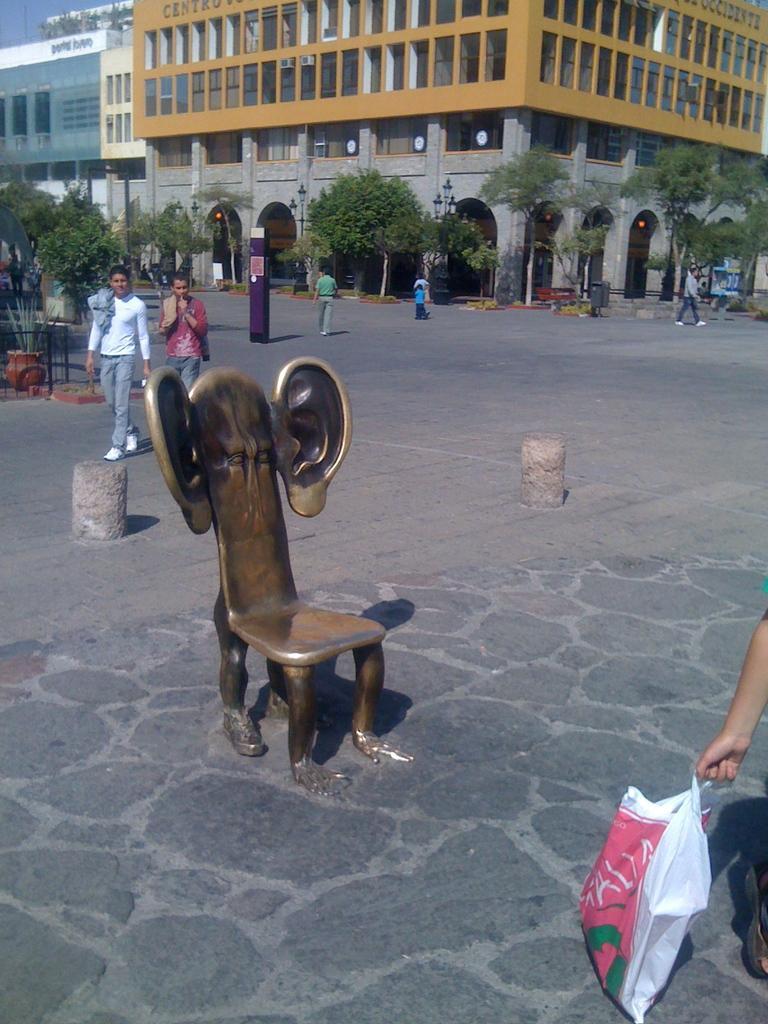How would you summarize this image in a sentence or two? In this image we can see group of people standing in the ground. One person is holding a bag in his hand. In the foreground of the image we can see a chair placed on the ground with set of ears on it. In the background we can see group of trees ,buildings and sky. 